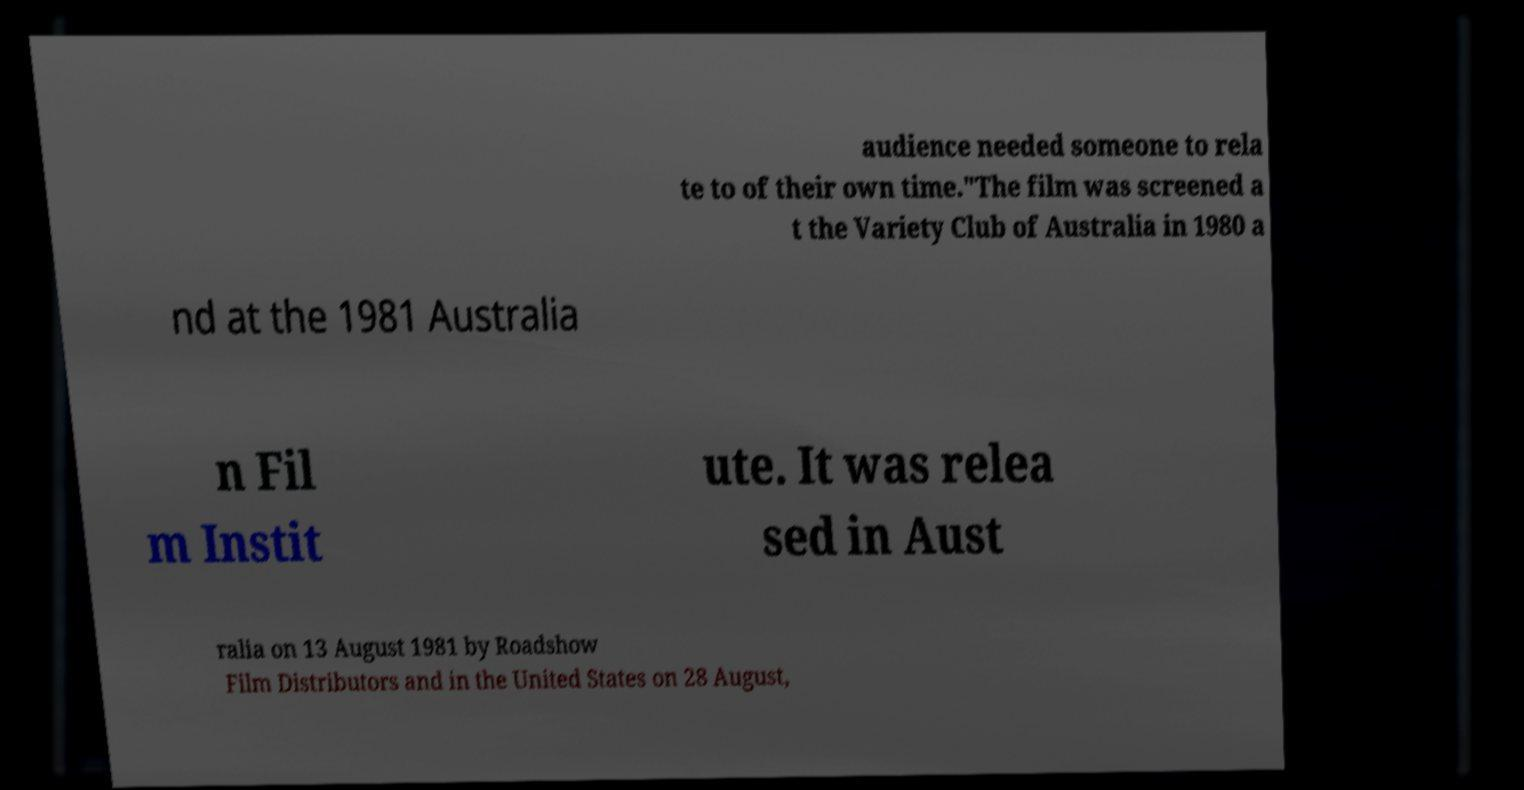I need the written content from this picture converted into text. Can you do that? audience needed someone to rela te to of their own time."The film was screened a t the Variety Club of Australia in 1980 a nd at the 1981 Australia n Fil m Instit ute. It was relea sed in Aust ralia on 13 August 1981 by Roadshow Film Distributors and in the United States on 28 August, 